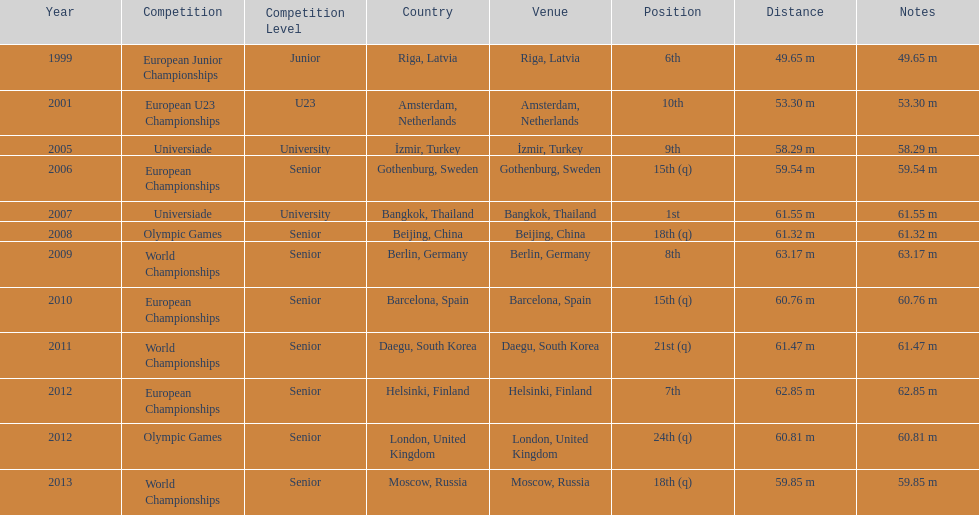Before competing in the 2012 olympics, what was his most recent contest? European Championships. 